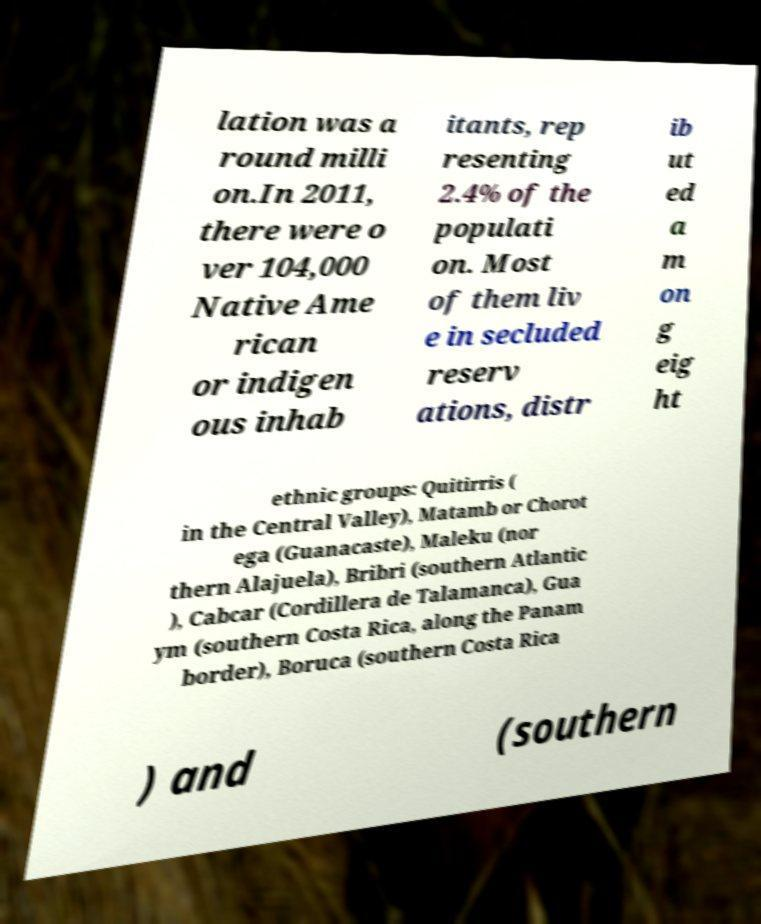Can you read and provide the text displayed in the image?This photo seems to have some interesting text. Can you extract and type it out for me? lation was a round milli on.In 2011, there were o ver 104,000 Native Ame rican or indigen ous inhab itants, rep resenting 2.4% of the populati on. Most of them liv e in secluded reserv ations, distr ib ut ed a m on g eig ht ethnic groups: Quitirris ( in the Central Valley), Matamb or Chorot ega (Guanacaste), Maleku (nor thern Alajuela), Bribri (southern Atlantic ), Cabcar (Cordillera de Talamanca), Gua ym (southern Costa Rica, along the Panam border), Boruca (southern Costa Rica ) and (southern 